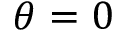Convert formula to latex. <formula><loc_0><loc_0><loc_500><loc_500>\theta = 0</formula> 